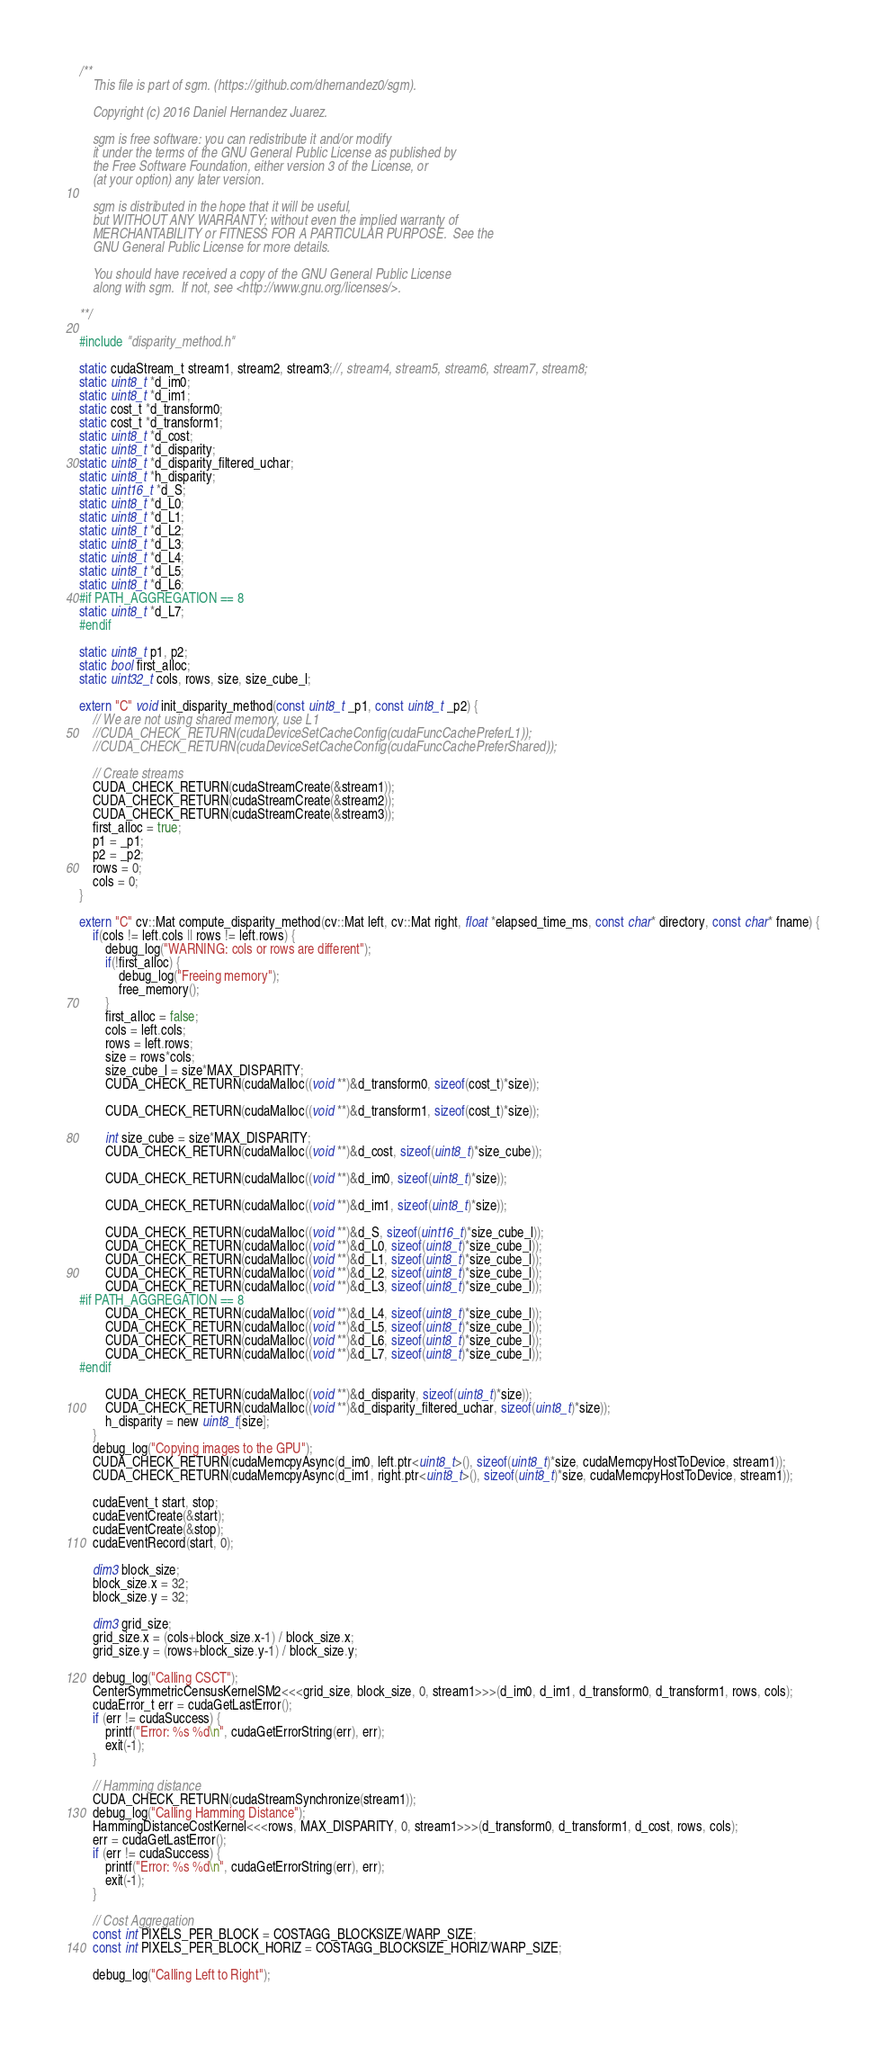Convert code to text. <code><loc_0><loc_0><loc_500><loc_500><_Cuda_>/**
    This file is part of sgm. (https://github.com/dhernandez0/sgm).

    Copyright (c) 2016 Daniel Hernandez Juarez.

    sgm is free software: you can redistribute it and/or modify
    it under the terms of the GNU General Public License as published by
    the Free Software Foundation, either version 3 of the License, or
    (at your option) any later version.

    sgm is distributed in the hope that it will be useful,
    but WITHOUT ANY WARRANTY; without even the implied warranty of
    MERCHANTABILITY or FITNESS FOR A PARTICULAR PURPOSE.  See the
    GNU General Public License for more details.

    You should have received a copy of the GNU General Public License
    along with sgm.  If not, see <http://www.gnu.org/licenses/>.

**/

#include "disparity_method.h"

static cudaStream_t stream1, stream2, stream3;//, stream4, stream5, stream6, stream7, stream8;
static uint8_t *d_im0;
static uint8_t *d_im1;
static cost_t *d_transform0;
static cost_t *d_transform1;
static uint8_t *d_cost;
static uint8_t *d_disparity;
static uint8_t *d_disparity_filtered_uchar;
static uint8_t *h_disparity;
static uint16_t *d_S;
static uint8_t *d_L0;
static uint8_t *d_L1;
static uint8_t *d_L2;
static uint8_t *d_L3;
static uint8_t *d_L4;
static uint8_t *d_L5;
static uint8_t *d_L6;
#if PATH_AGGREGATION == 8
static uint8_t *d_L7;
#endif

static uint8_t p1, p2;
static bool first_alloc;
static uint32_t cols, rows, size, size_cube_l;

extern "C" void init_disparity_method(const uint8_t _p1, const uint8_t _p2) {
	// We are not using shared memory, use L1
	//CUDA_CHECK_RETURN(cudaDeviceSetCacheConfig(cudaFuncCachePreferL1));
	//CUDA_CHECK_RETURN(cudaDeviceSetCacheConfig(cudaFuncCachePreferShared));

	// Create streams
	CUDA_CHECK_RETURN(cudaStreamCreate(&stream1));
	CUDA_CHECK_RETURN(cudaStreamCreate(&stream2));
	CUDA_CHECK_RETURN(cudaStreamCreate(&stream3));
	first_alloc = true;
	p1 = _p1;
	p2 = _p2;
    rows = 0;
    cols = 0;
}

extern "C" cv::Mat compute_disparity_method(cv::Mat left, cv::Mat right, float *elapsed_time_ms, const char* directory, const char* fname) {
	if(cols != left.cols || rows != left.rows) {
		debug_log("WARNING: cols or rows are different");
		if(!first_alloc) {
			debug_log("Freeing memory");
			free_memory();
		}
		first_alloc = false;
		cols = left.cols;
		rows = left.rows;
		size = rows*cols;
		size_cube_l = size*MAX_DISPARITY;
		CUDA_CHECK_RETURN(cudaMalloc((void **)&d_transform0, sizeof(cost_t)*size));

		CUDA_CHECK_RETURN(cudaMalloc((void **)&d_transform1, sizeof(cost_t)*size));

		int size_cube = size*MAX_DISPARITY;
		CUDA_CHECK_RETURN(cudaMalloc((void **)&d_cost, sizeof(uint8_t)*size_cube));

		CUDA_CHECK_RETURN(cudaMalloc((void **)&d_im0, sizeof(uint8_t)*size));

		CUDA_CHECK_RETURN(cudaMalloc((void **)&d_im1, sizeof(uint8_t)*size));

		CUDA_CHECK_RETURN(cudaMalloc((void **)&d_S, sizeof(uint16_t)*size_cube_l));
		CUDA_CHECK_RETURN(cudaMalloc((void **)&d_L0, sizeof(uint8_t)*size_cube_l));
		CUDA_CHECK_RETURN(cudaMalloc((void **)&d_L1, sizeof(uint8_t)*size_cube_l));
		CUDA_CHECK_RETURN(cudaMalloc((void **)&d_L2, sizeof(uint8_t)*size_cube_l));
		CUDA_CHECK_RETURN(cudaMalloc((void **)&d_L3, sizeof(uint8_t)*size_cube_l));
#if PATH_AGGREGATION == 8
		CUDA_CHECK_RETURN(cudaMalloc((void **)&d_L4, sizeof(uint8_t)*size_cube_l));
		CUDA_CHECK_RETURN(cudaMalloc((void **)&d_L5, sizeof(uint8_t)*size_cube_l));
		CUDA_CHECK_RETURN(cudaMalloc((void **)&d_L6, sizeof(uint8_t)*size_cube_l));
		CUDA_CHECK_RETURN(cudaMalloc((void **)&d_L7, sizeof(uint8_t)*size_cube_l));
#endif

		CUDA_CHECK_RETURN(cudaMalloc((void **)&d_disparity, sizeof(uint8_t)*size));
		CUDA_CHECK_RETURN(cudaMalloc((void **)&d_disparity_filtered_uchar, sizeof(uint8_t)*size));
		h_disparity = new uint8_t[size];
	}
	debug_log("Copying images to the GPU");
	CUDA_CHECK_RETURN(cudaMemcpyAsync(d_im0, left.ptr<uint8_t>(), sizeof(uint8_t)*size, cudaMemcpyHostToDevice, stream1));
	CUDA_CHECK_RETURN(cudaMemcpyAsync(d_im1, right.ptr<uint8_t>(), sizeof(uint8_t)*size, cudaMemcpyHostToDevice, stream1));

	cudaEvent_t start, stop;
	cudaEventCreate(&start);
	cudaEventCreate(&stop);
	cudaEventRecord(start, 0);

	dim3 block_size;
	block_size.x = 32;
	block_size.y = 32;

	dim3 grid_size;
	grid_size.x = (cols+block_size.x-1) / block_size.x;
	grid_size.y = (rows+block_size.y-1) / block_size.y;

	debug_log("Calling CSCT");
	CenterSymmetricCensusKernelSM2<<<grid_size, block_size, 0, stream1>>>(d_im0, d_im1, d_transform0, d_transform1, rows, cols);
	cudaError_t err = cudaGetLastError();
	if (err != cudaSuccess) {
		printf("Error: %s %d\n", cudaGetErrorString(err), err);
		exit(-1);
	}

	// Hamming distance
	CUDA_CHECK_RETURN(cudaStreamSynchronize(stream1));
	debug_log("Calling Hamming Distance");
	HammingDistanceCostKernel<<<rows, MAX_DISPARITY, 0, stream1>>>(d_transform0, d_transform1, d_cost, rows, cols);
	err = cudaGetLastError();
	if (err != cudaSuccess) {
		printf("Error: %s %d\n", cudaGetErrorString(err), err);
		exit(-1);
	}

	// Cost Aggregation
	const int PIXELS_PER_BLOCK = COSTAGG_BLOCKSIZE/WARP_SIZE;
	const int PIXELS_PER_BLOCK_HORIZ = COSTAGG_BLOCKSIZE_HORIZ/WARP_SIZE;

	debug_log("Calling Left to Right");</code> 